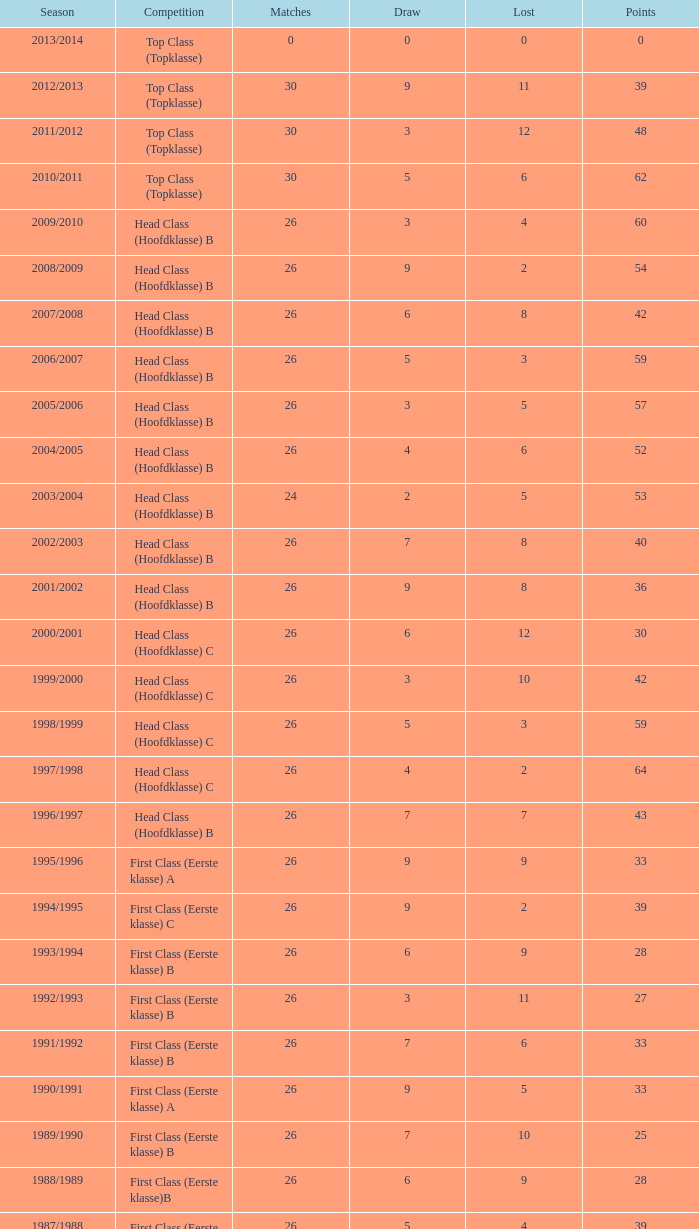What competition has a score greater than 30, a draw less than 5, and a loss larger than 10? Top Class (Topklasse). 